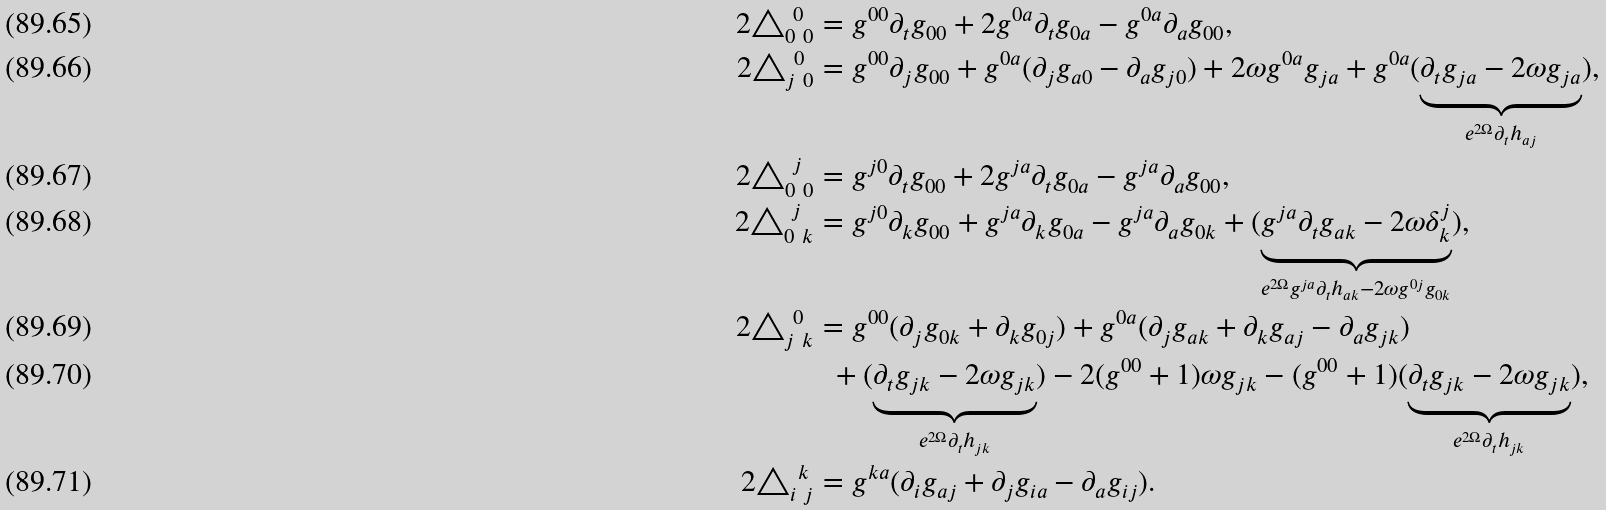<formula> <loc_0><loc_0><loc_500><loc_500>2 \triangle _ { 0 \ 0 } ^ { \ 0 } & = g ^ { 0 0 } \partial _ { t } g _ { 0 0 } + 2 g ^ { 0 a } \partial _ { t } g _ { 0 a } - g ^ { 0 a } \partial _ { a } g _ { 0 0 } , \\ 2 \triangle _ { j \ 0 } ^ { \ 0 } & = g ^ { 0 0 } \partial _ { j } g _ { 0 0 } + g ^ { 0 a } ( \partial _ { j } g _ { a 0 } - \partial _ { a } g _ { j 0 } ) + 2 \omega g ^ { 0 a } g _ { j a } + g ^ { 0 a } ( \underbrace { \partial _ { t } g _ { j a } - 2 \omega g _ { j a } } _ { e ^ { 2 \Omega } \partial _ { t } h _ { a j } } ) , \\ 2 \triangle _ { 0 \ 0 } ^ { \ j } & = g ^ { j 0 } \partial _ { t } g _ { 0 0 } + 2 g ^ { j a } \partial _ { t } g _ { 0 a } - g ^ { j a } \partial _ { a } g _ { 0 0 } , \\ 2 \triangle _ { 0 \ k } ^ { \ j } & = g ^ { j 0 } \partial _ { k } g _ { 0 0 } + g ^ { j a } \partial _ { k } g _ { 0 a } - g ^ { j a } \partial _ { a } g _ { 0 k } + ( \underbrace { g ^ { j a } \partial _ { t } g _ { a k } - 2 \omega \delta _ { k } ^ { j } } _ { e ^ { 2 \Omega } g ^ { j a } \partial _ { t } h _ { a k } - 2 \omega g ^ { 0 j } g _ { 0 k } } ) , \\ 2 \triangle _ { j \ k } ^ { \ 0 } & = g ^ { 0 0 } ( \partial _ { j } g _ { 0 k } + \partial _ { k } g _ { 0 j } ) + g ^ { 0 a } ( \partial _ { j } g _ { a k } + \partial _ { k } g _ { a j } - \partial _ { a } g _ { j k } ) \\ & \ \ + ( \underbrace { \partial _ { t } g _ { j k } - 2 \omega g _ { j k } } _ { e ^ { 2 \Omega } \partial _ { t } h _ { j k } } ) - 2 ( g ^ { 0 0 } + 1 ) \omega g _ { j k } - ( g ^ { 0 0 } + 1 ) ( \underbrace { \partial _ { t } g _ { j k } - 2 \omega g _ { j k } } _ { e ^ { 2 \Omega } \partial _ { t } h _ { j k } } ) , \\ 2 \triangle _ { i \ j } ^ { \ k } & = g ^ { k a } ( \partial _ { i } g _ { a j } + \partial _ { j } g _ { i a } - \partial _ { a } g _ { i j } ) .</formula> 